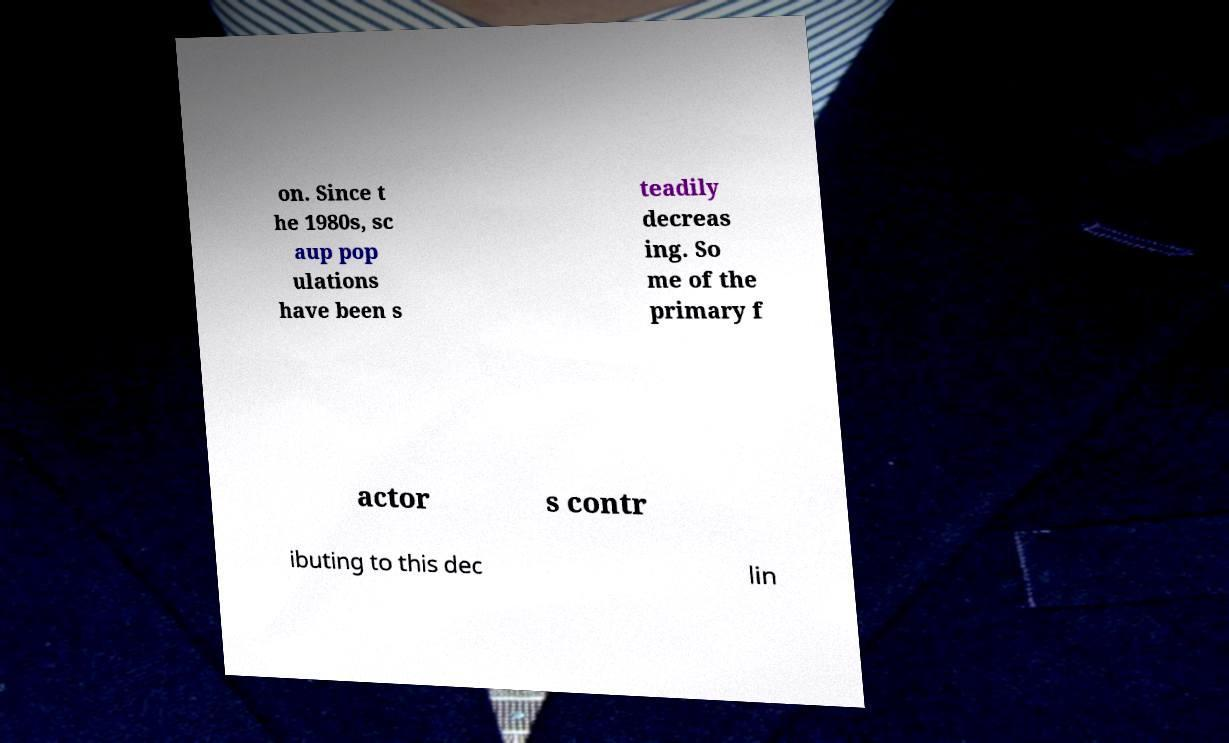I need the written content from this picture converted into text. Can you do that? on. Since t he 1980s, sc aup pop ulations have been s teadily decreas ing. So me of the primary f actor s contr ibuting to this dec lin 